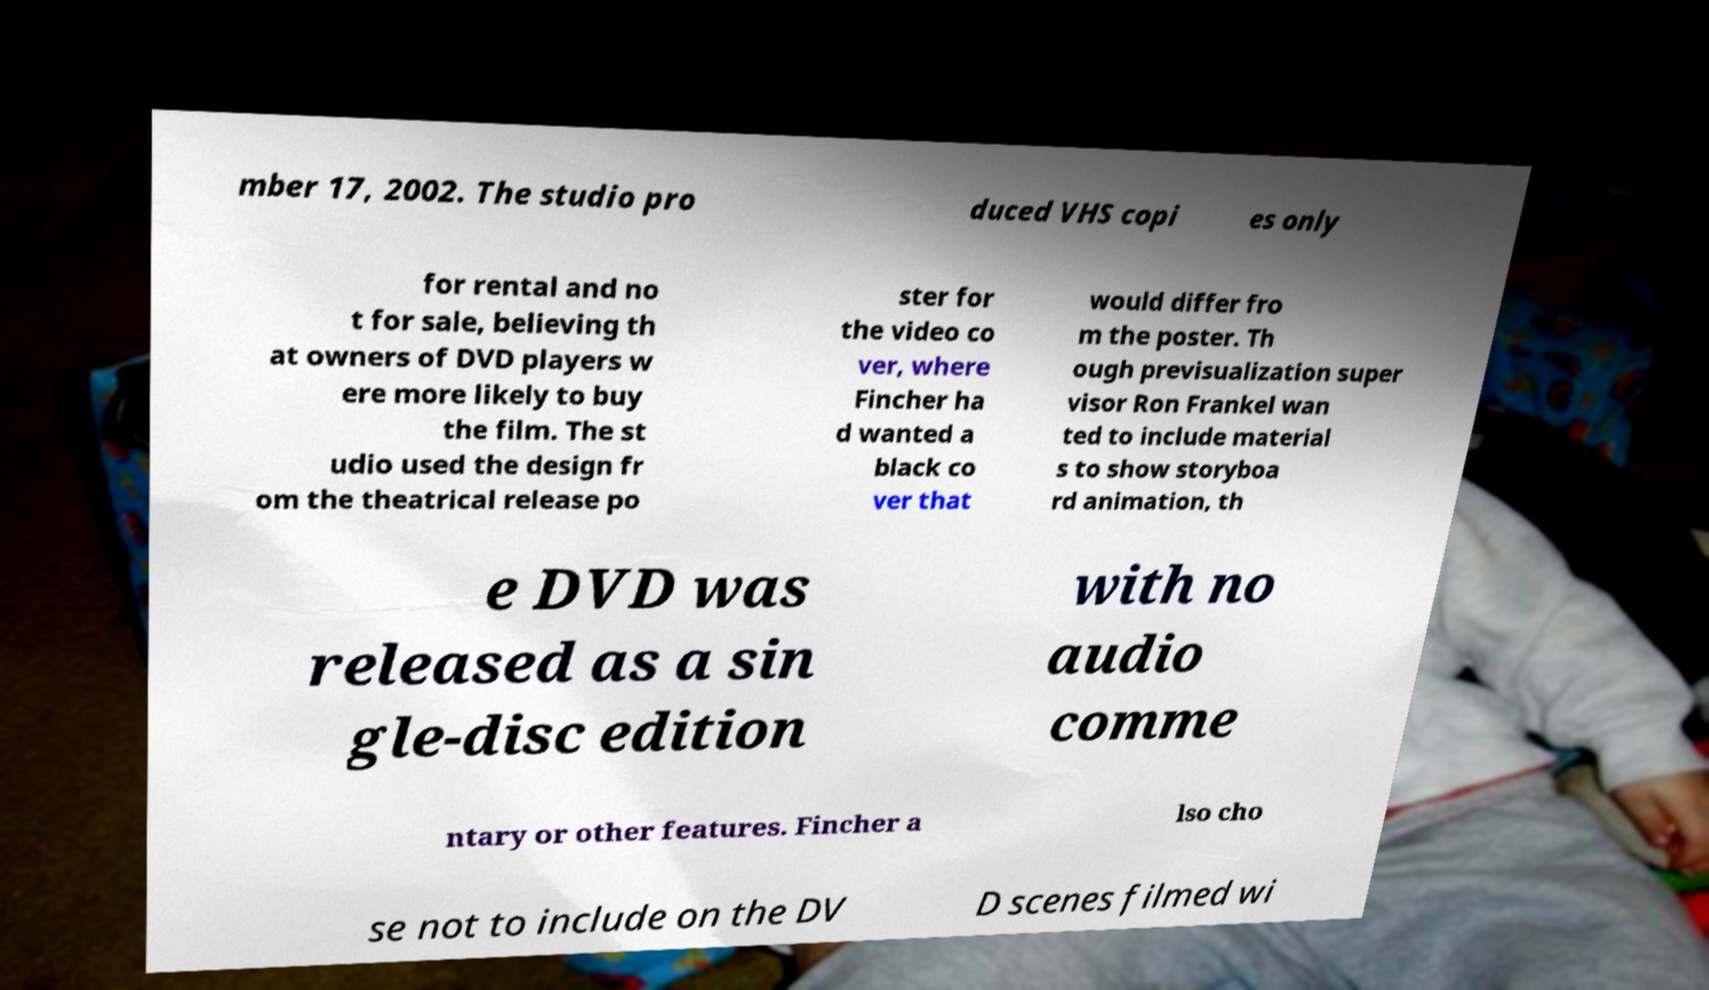Please identify and transcribe the text found in this image. mber 17, 2002. The studio pro duced VHS copi es only for rental and no t for sale, believing th at owners of DVD players w ere more likely to buy the film. The st udio used the design fr om the theatrical release po ster for the video co ver, where Fincher ha d wanted a black co ver that would differ fro m the poster. Th ough previsualization super visor Ron Frankel wan ted to include material s to show storyboa rd animation, th e DVD was released as a sin gle-disc edition with no audio comme ntary or other features. Fincher a lso cho se not to include on the DV D scenes filmed wi 